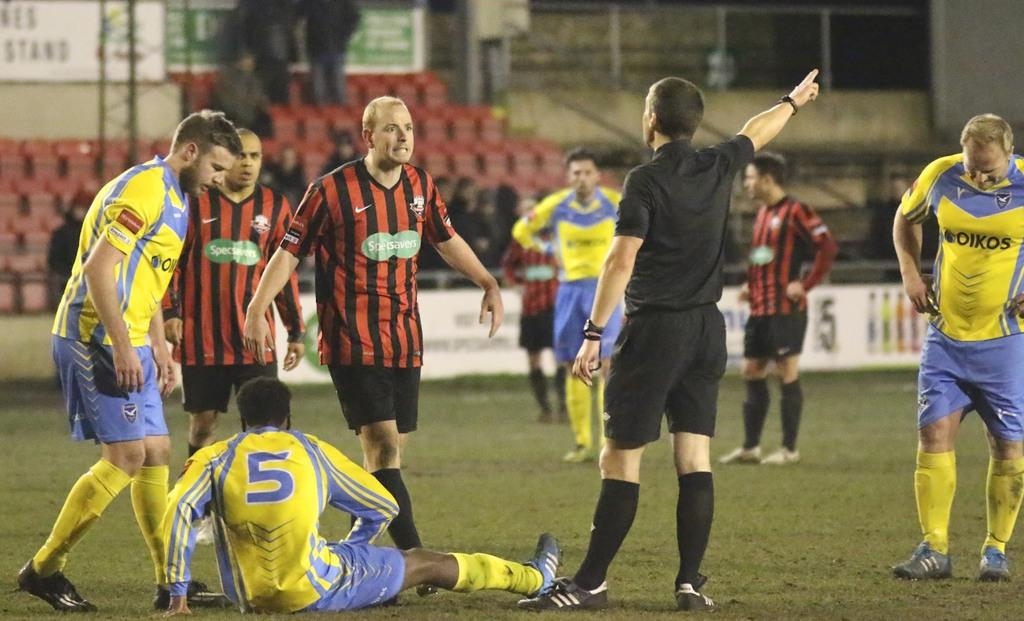<image>
Offer a succinct explanation of the picture presented. A soccer team wearing yellow and blue jerseys with the word Oikos on the front. 